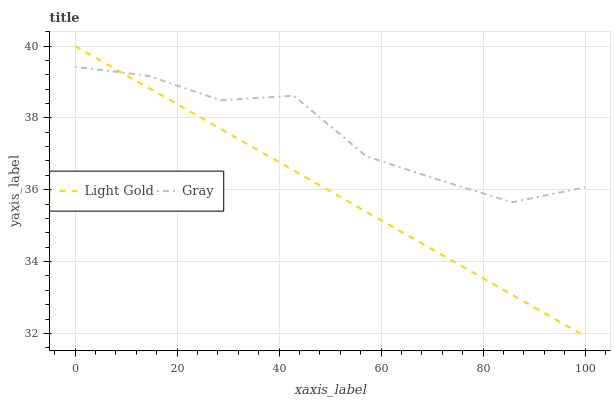Does Light Gold have the minimum area under the curve?
Answer yes or no. Yes. Does Gray have the maximum area under the curve?
Answer yes or no. Yes. Does Light Gold have the maximum area under the curve?
Answer yes or no. No. Is Light Gold the smoothest?
Answer yes or no. Yes. Is Gray the roughest?
Answer yes or no. Yes. Is Light Gold the roughest?
Answer yes or no. No. Does Light Gold have the lowest value?
Answer yes or no. Yes. Does Light Gold have the highest value?
Answer yes or no. Yes. Does Light Gold intersect Gray?
Answer yes or no. Yes. Is Light Gold less than Gray?
Answer yes or no. No. Is Light Gold greater than Gray?
Answer yes or no. No. 